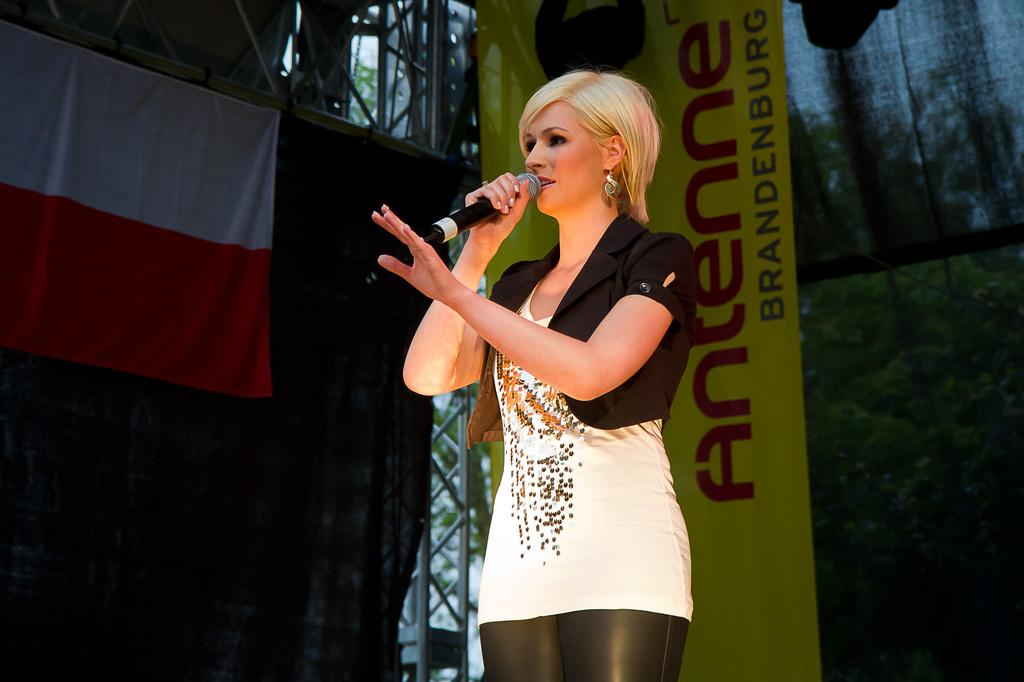What can be seen hanging or displayed in the image? There is a banner in the image. What is the woman in the image doing? The woman is holding a microphone in the image. How many trucks are visible in the image? There are no trucks present in the image. Is there a boy holding the microphone with the woman in the image? There is no boy present in the image; only a woman holding a microphone. 